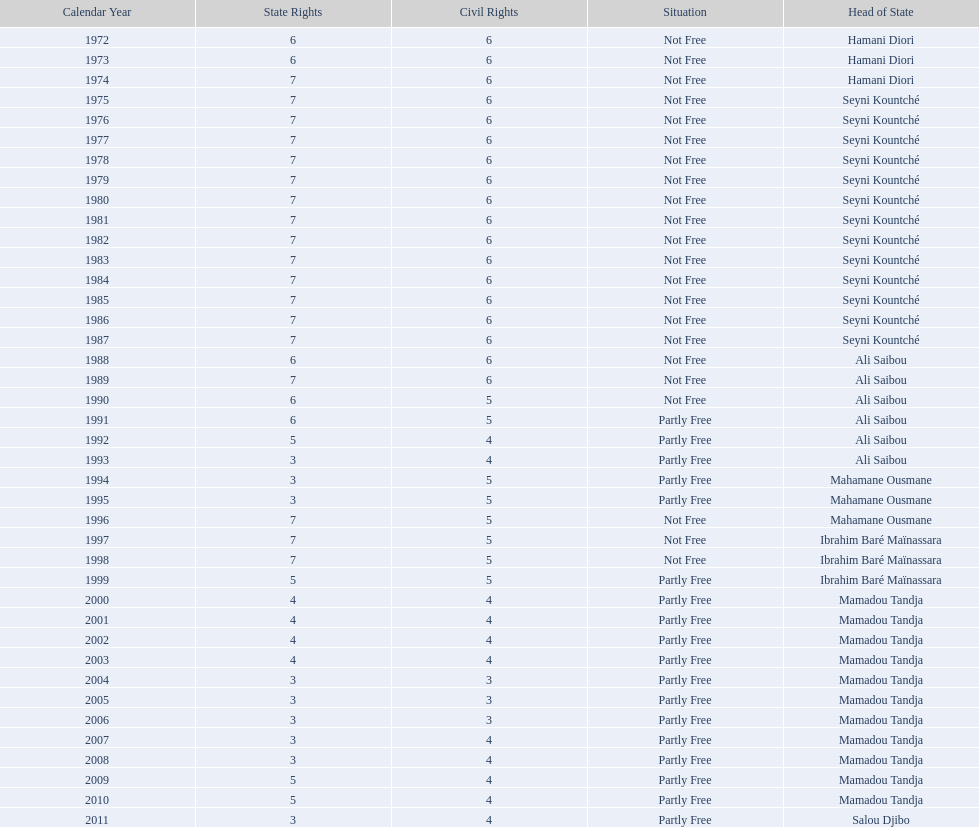How many years elapsed prior to the first partially free status? 18. 